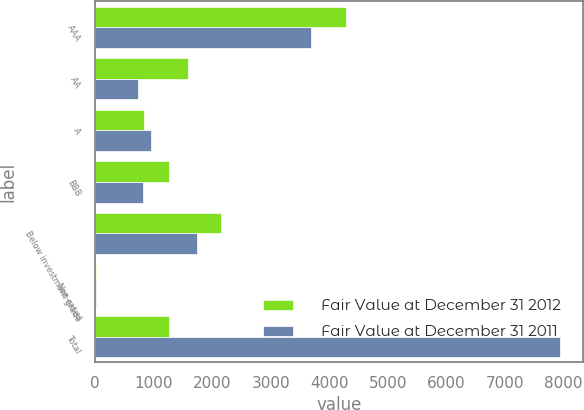Convert chart. <chart><loc_0><loc_0><loc_500><loc_500><stacked_bar_chart><ecel><fcel>AAA<fcel>AA<fcel>A<fcel>BBB<fcel>Below investment grade<fcel>Non-rated<fcel>Total<nl><fcel>Fair Value at December 31 2012<fcel>4278<fcel>1591<fcel>827<fcel>1266<fcel>2156<fcel>16<fcel>1266<nl><fcel>Fair Value at December 31 2011<fcel>3693<fcel>734<fcel>948<fcel>818<fcel>1740<fcel>13<fcel>7946<nl></chart> 